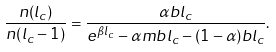Convert formula to latex. <formula><loc_0><loc_0><loc_500><loc_500>\frac { n ( l _ { c } ) } { n ( l _ { c } - 1 ) } = \frac { \alpha b l _ { c } } { e ^ { \beta l _ { c } } - \alpha m b l _ { c } - ( 1 - \alpha ) b l _ { c } } .</formula> 